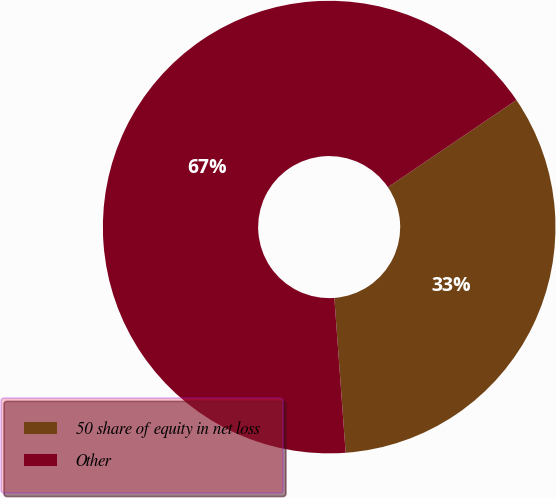<chart> <loc_0><loc_0><loc_500><loc_500><pie_chart><fcel>50 share of equity in net loss<fcel>Other<nl><fcel>33.33%<fcel>66.67%<nl></chart> 